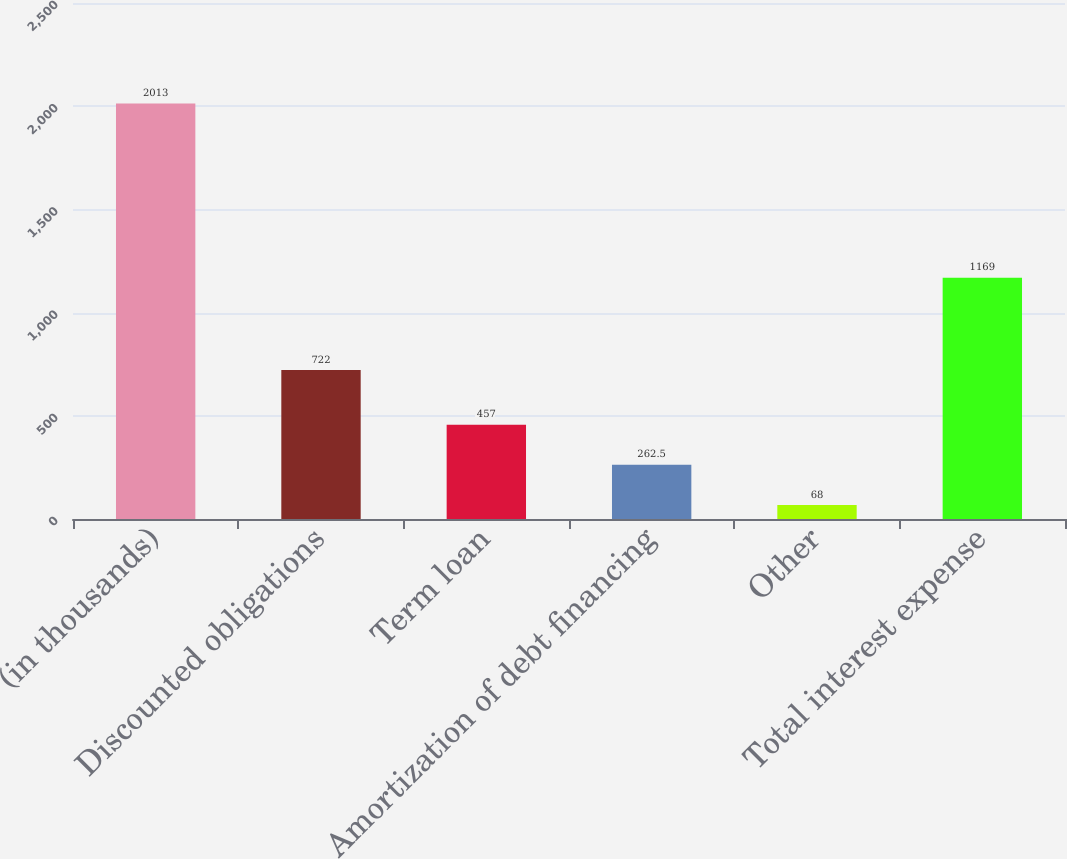Convert chart. <chart><loc_0><loc_0><loc_500><loc_500><bar_chart><fcel>(in thousands)<fcel>Discounted obligations<fcel>Term loan<fcel>Amortization of debt financing<fcel>Other<fcel>Total interest expense<nl><fcel>2013<fcel>722<fcel>457<fcel>262.5<fcel>68<fcel>1169<nl></chart> 